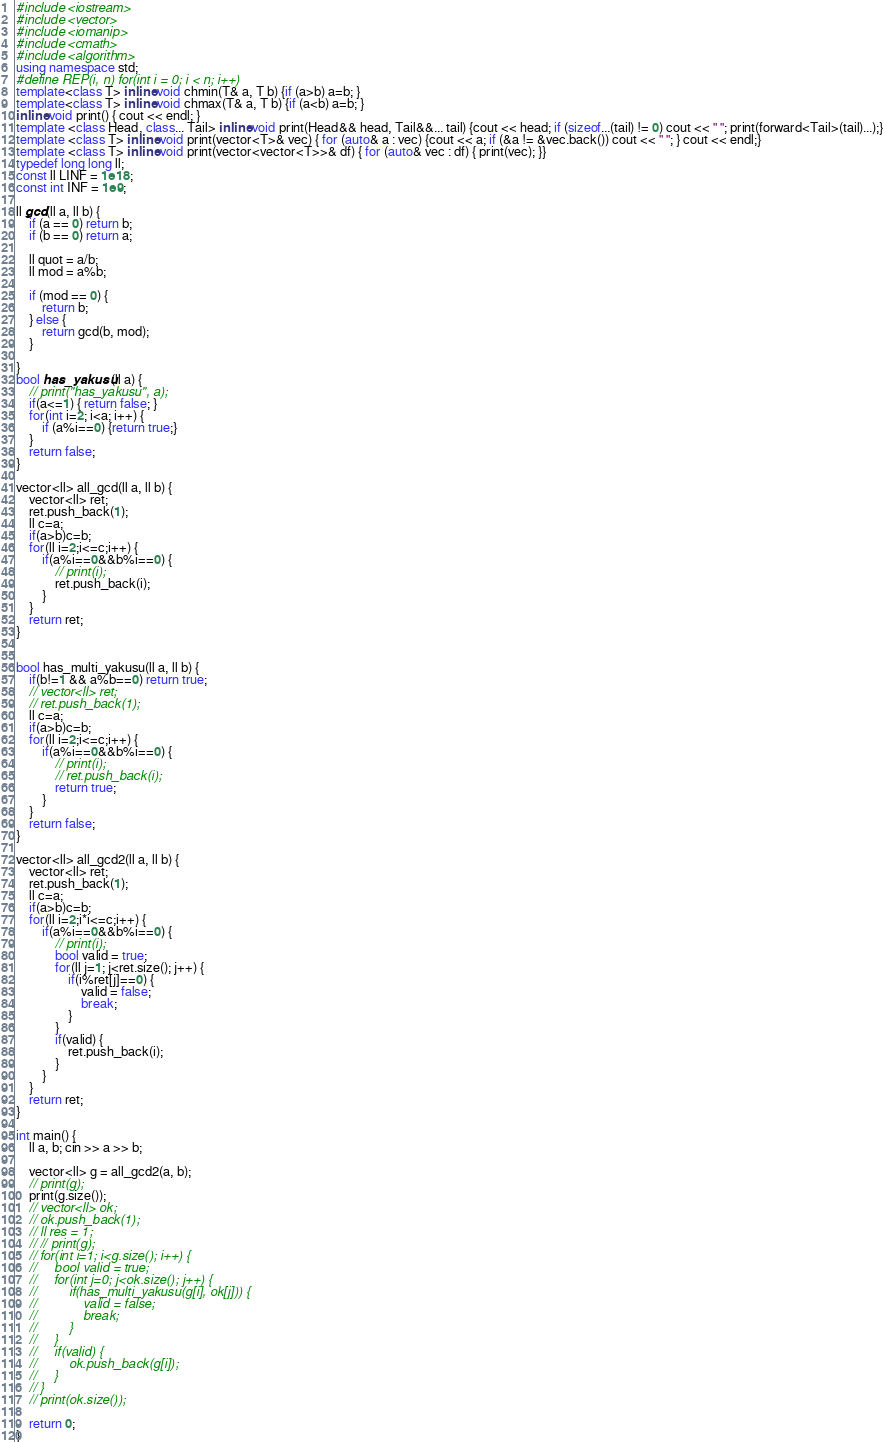<code> <loc_0><loc_0><loc_500><loc_500><_C++_>#include <iostream>
#include <vector>
#include <iomanip>
#include <cmath>
#include <algorithm>
using namespace std;
#define REP(i, n) for(int i = 0; i < n; i++)
template<class T> inline void chmin(T& a, T b) {if (a>b) a=b; }
template<class T> inline void chmax(T& a, T b) {if (a<b) a=b; }
inline void print() { cout << endl; }
template <class Head, class... Tail> inline void print(Head&& head, Tail&&... tail) {cout << head; if (sizeof...(tail) != 0) cout << " "; print(forward<Tail>(tail)...);}
template <class T> inline void print(vector<T>& vec) { for (auto& a : vec) {cout << a; if (&a != &vec.back()) cout << " "; } cout << endl;}
template <class T> inline void print(vector<vector<T>>& df) { for (auto& vec : df) { print(vec); }}
typedef long long ll;
const ll LINF = 1e18;
const int INF = 1e9;

ll gcd(ll a, ll b) {
    if (a == 0) return b;
    if (b == 0) return a;

    ll quot = a/b;
    ll mod = a%b;
    
    if (mod == 0) {
        return b;
    } else {
        return gcd(b, mod);
    }

}
bool has_yakusu(ll a) {
    // print("has_yakusu", a);
    if(a<=1) { return false; }
    for(int i=2; i<a; i++) {
        if (a%i==0) {return true;}
    }
    return false;
}

vector<ll> all_gcd(ll a, ll b) {
    vector<ll> ret;
    ret.push_back(1);
    ll c=a;
    if(a>b)c=b;
    for(ll i=2;i<=c;i++) {
        if(a%i==0&&b%i==0) {
            // print(i);
            ret.push_back(i);
        }
    }
    return ret;
}


bool has_multi_yakusu(ll a, ll b) {
    if(b!=1 && a%b==0) return true;
    // vector<ll> ret;
    // ret.push_back(1);
    ll c=a;
    if(a>b)c=b;
    for(ll i=2;i<=c;i++) {
        if(a%i==0&&b%i==0) {
            // print(i);
            // ret.push_back(i);
            return true;
        }
    }
    return false;
}

vector<ll> all_gcd2(ll a, ll b) {
    vector<ll> ret;
    ret.push_back(1);
    ll c=a;
    if(a>b)c=b;
    for(ll i=2;i*i<=c;i++) {
        if(a%i==0&&b%i==0) {
            // print(i);
            bool valid = true;
            for(ll j=1; j<ret.size(); j++) {
                if(i%ret[j]==0) {
                    valid = false;
                    break;
                }
            }
            if(valid) {
                ret.push_back(i);
            }
        }
    }
    return ret;
}

int main() { 
    ll a, b; cin >> a >> b;

    vector<ll> g = all_gcd2(a, b);
    // print(g);
    print(g.size());
    // vector<ll> ok;
    // ok.push_back(1);
    // ll res = 1;
    // // print(g);
    // for(int i=1; i<g.size(); i++) {
    //     bool valid = true;
    //     for(int j=0; j<ok.size(); j++) {
    //         if(has_multi_yakusu(g[i], ok[j])) {
    //             valid = false;
    //             break;
    //         }
    //     }
    //     if(valid) {
    //         ok.push_back(g[i]);
    //     }
    // }
    // print(ok.size());

    return 0;
}</code> 